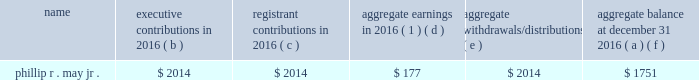2016 non-qualified deferred compensation as of december 31 , 2016 , mr .
May had a deferred account balance under a frozen defined contribution restoration plan .
The amount is deemed invested , as chosen by the participant , in certain t .
Rowe price investment funds that are also available to the participant under the savings plan .
Mr .
May has elected to receive the deferred account balance after he retires .
The defined contribution restoration plan , until it was frozen in 2005 , credited eligible employees 2019 deferral accounts with employer contributions to the extent contributions under the qualified savings plan in which the employee participated were subject to limitations imposed by the code .
Defined contribution restoration plan executive contributions in registrant contributions in aggregate earnings in 2016 ( 1 ) aggregate withdrawals/ distributions aggregate balance at december 31 , ( a ) ( b ) ( c ) ( d ) ( e ) ( f ) .
( 1 ) amounts in this column are not included in the summary compensation table .
2016 potential payments upon termination or change in control entergy corporation has plans and other arrangements that provide compensation to a named executive officer if his or her employment terminates under specified conditions , including following a change in control of entergy corporation .
In addition , in 2006 entergy corporation entered into a retention agreement with mr .
Denault that provides possibility of additional service credit under the system executive retirement plan upon certain terminations of employment .
There are no plans or agreements that would provide for payments to any of the named executive officers solely upon a change in control .
The tables below reflect the amount of compensation each of the named executive officers would have received if his or her employment with their entergy employer had been terminated under various scenarios as of december 31 , 2016 .
For purposes of these tables , a stock price of $ 73.47 was used , which was the closing market price on december 30 , 2016 , the last trading day of the year. .
What is the percentage change in the aggregate balance from 2015 to 2016 for phillip r . may jr.? 
Computations: (177 / (1751 - 177))
Answer: 0.11245. 